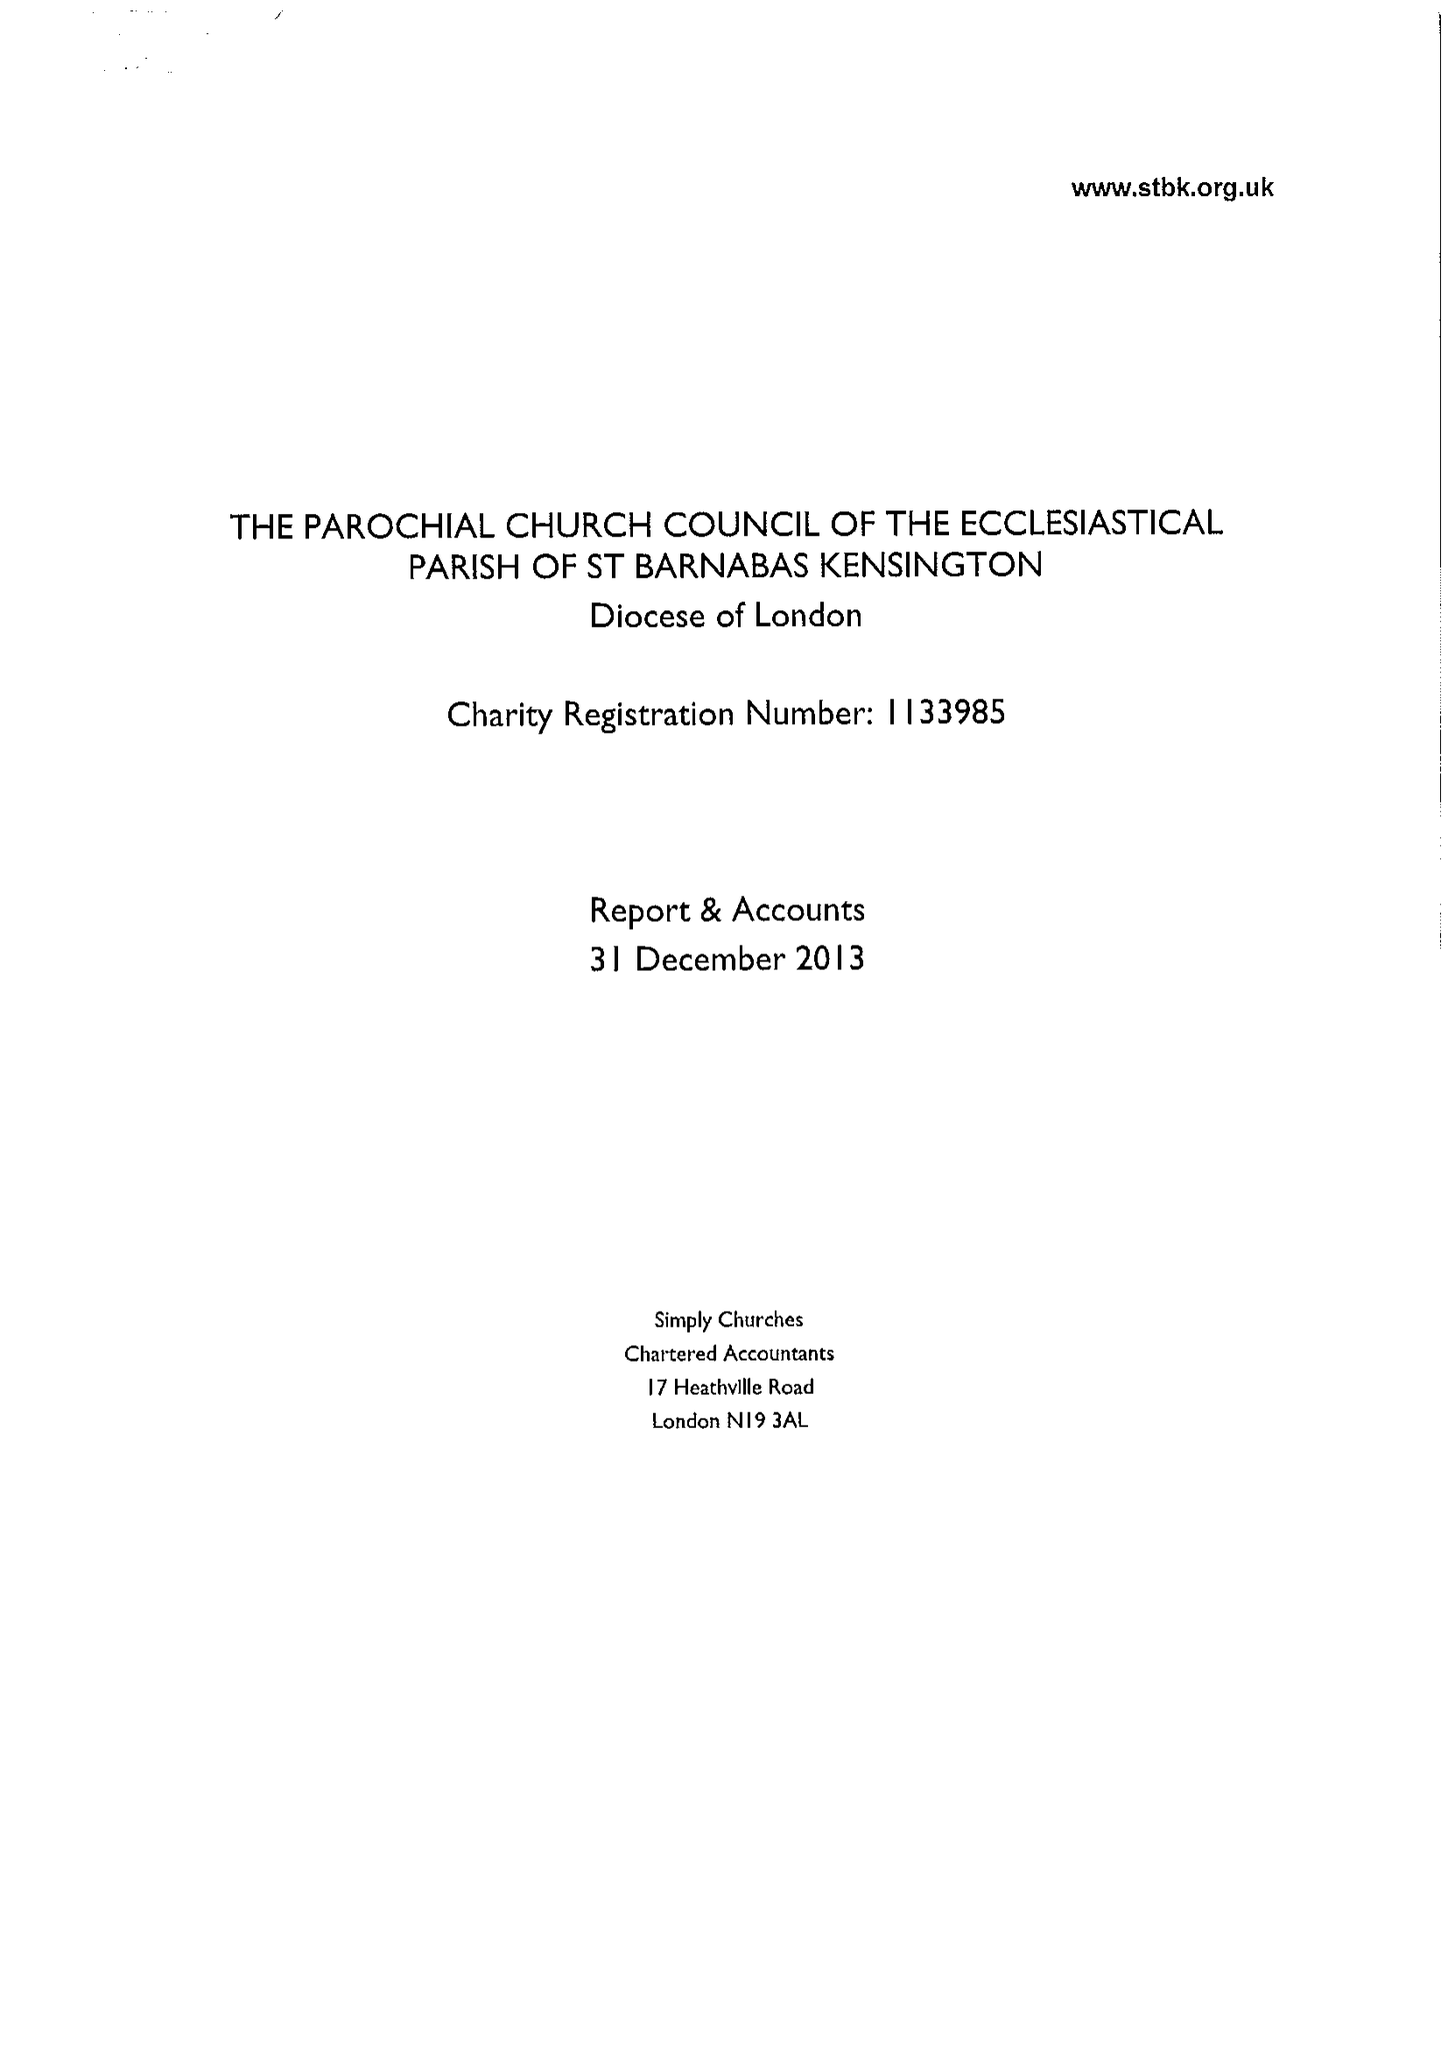What is the value for the address__postcode?
Answer the question using a single word or phrase. W14 8LH 